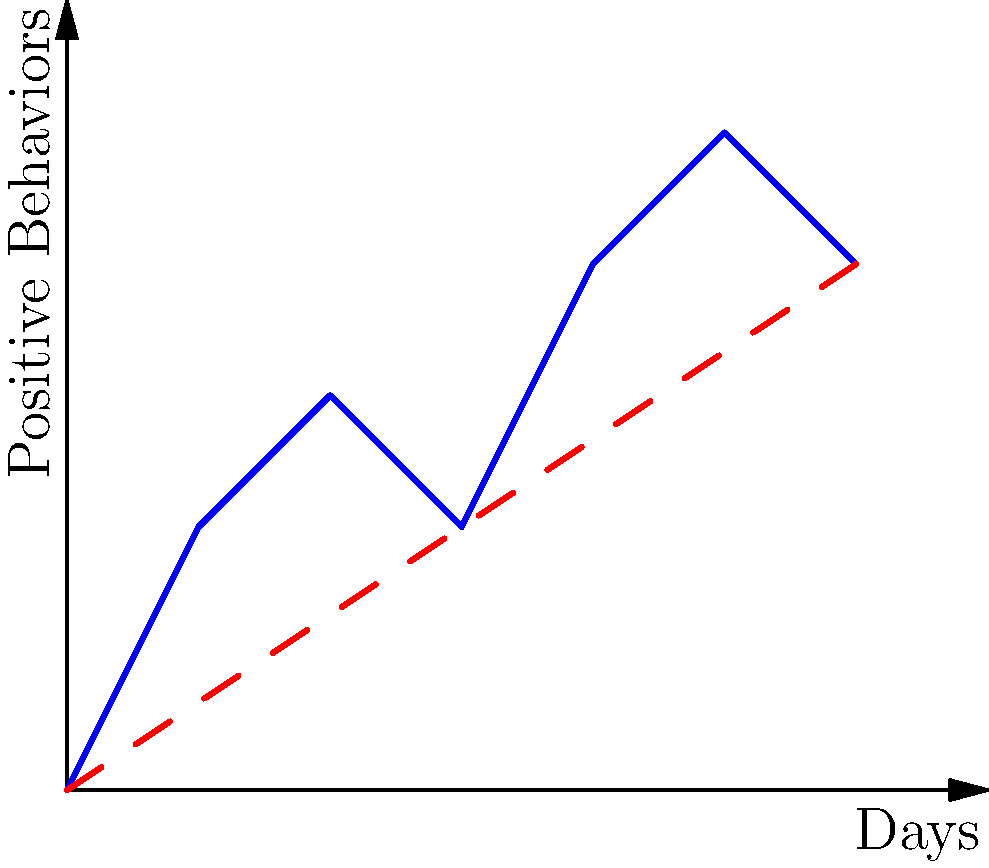A behavior chart has been created to track a child's positive behaviors over a week. The x-axis represents days (0-6), and the y-axis represents the number of positive behaviors (0-5). Given the chart, what is the slope of the trend line, and what does this indicate about the child's progress? To solve this problem, we need to follow these steps:

1. Identify the trend line: The red dashed line represents the overall trend of positive behaviors.

2. Find two points on the trend line: We can use the start and end points of the line.
   Start point: (0, 0)
   End point: (6, 4)

3. Calculate the slope using the formula:
   $$ \text{Slope} = \frac{y_2 - y_1}{x_2 - x_1} $$

   Where $(x_1, y_1)$ is the start point and $(x_2, y_2)$ is the end point.

4. Plug in the values:
   $$ \text{Slope} = \frac{4 - 0}{6 - 0} = \frac{4}{6} = \frac{2}{3} \approx 0.67 $$

5. Interpret the result:
   - The slope is positive, indicating an overall increase in positive behaviors over time.
   - The value of approximately 0.67 means that, on average, the child is showing about 2 more positive behaviors every 3 days.

This positive slope suggests that the reinforcement strategy is effective, as the child's positive behaviors are generally increasing over the week.
Answer: Slope = $\frac{2}{3}$ (≈0.67); indicates overall improvement in positive behaviors. 